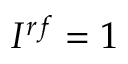<formula> <loc_0><loc_0><loc_500><loc_500>I ^ { r f } = 1</formula> 